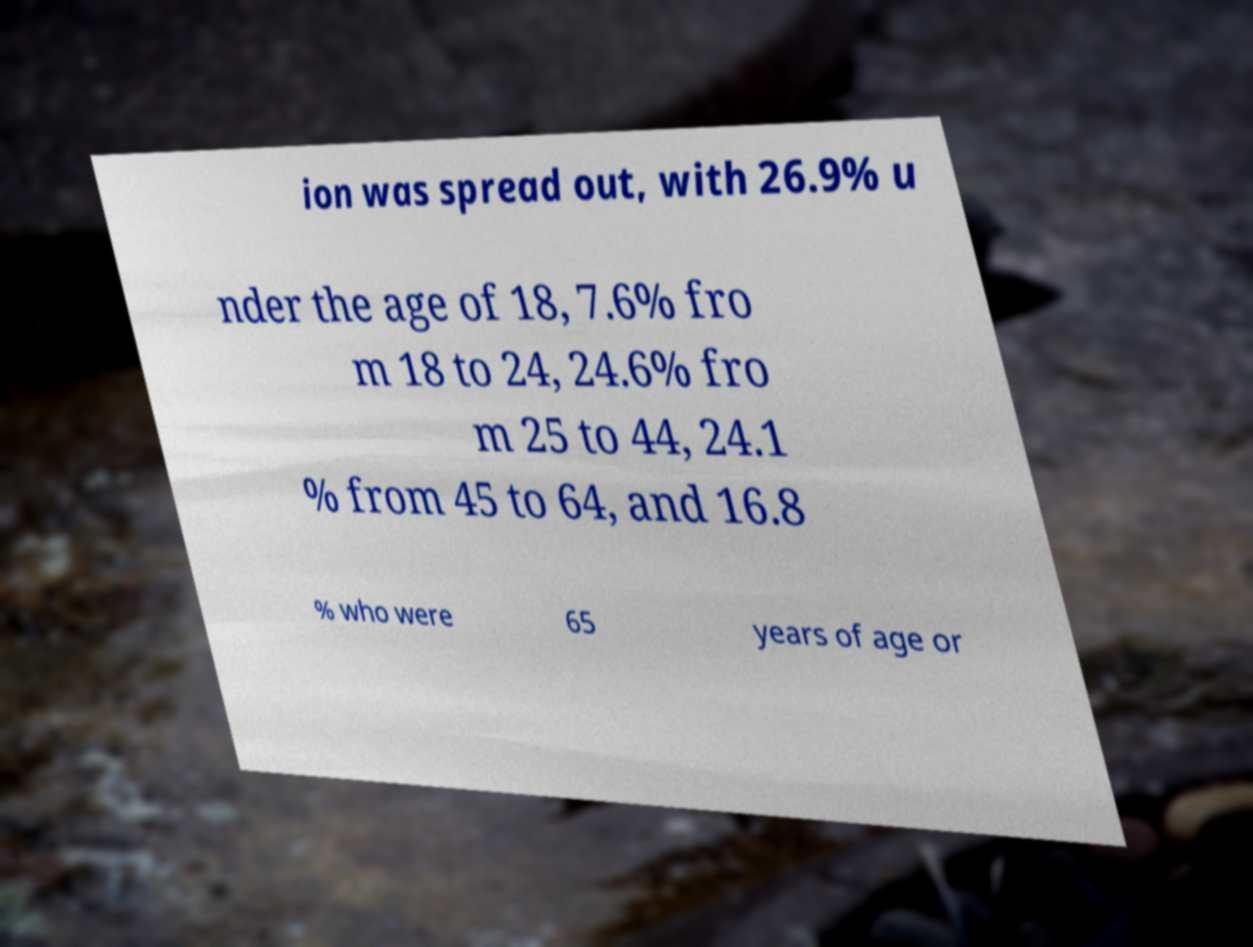Please read and relay the text visible in this image. What does it say? ion was spread out, with 26.9% u nder the age of 18, 7.6% fro m 18 to 24, 24.6% fro m 25 to 44, 24.1 % from 45 to 64, and 16.8 % who were 65 years of age or 